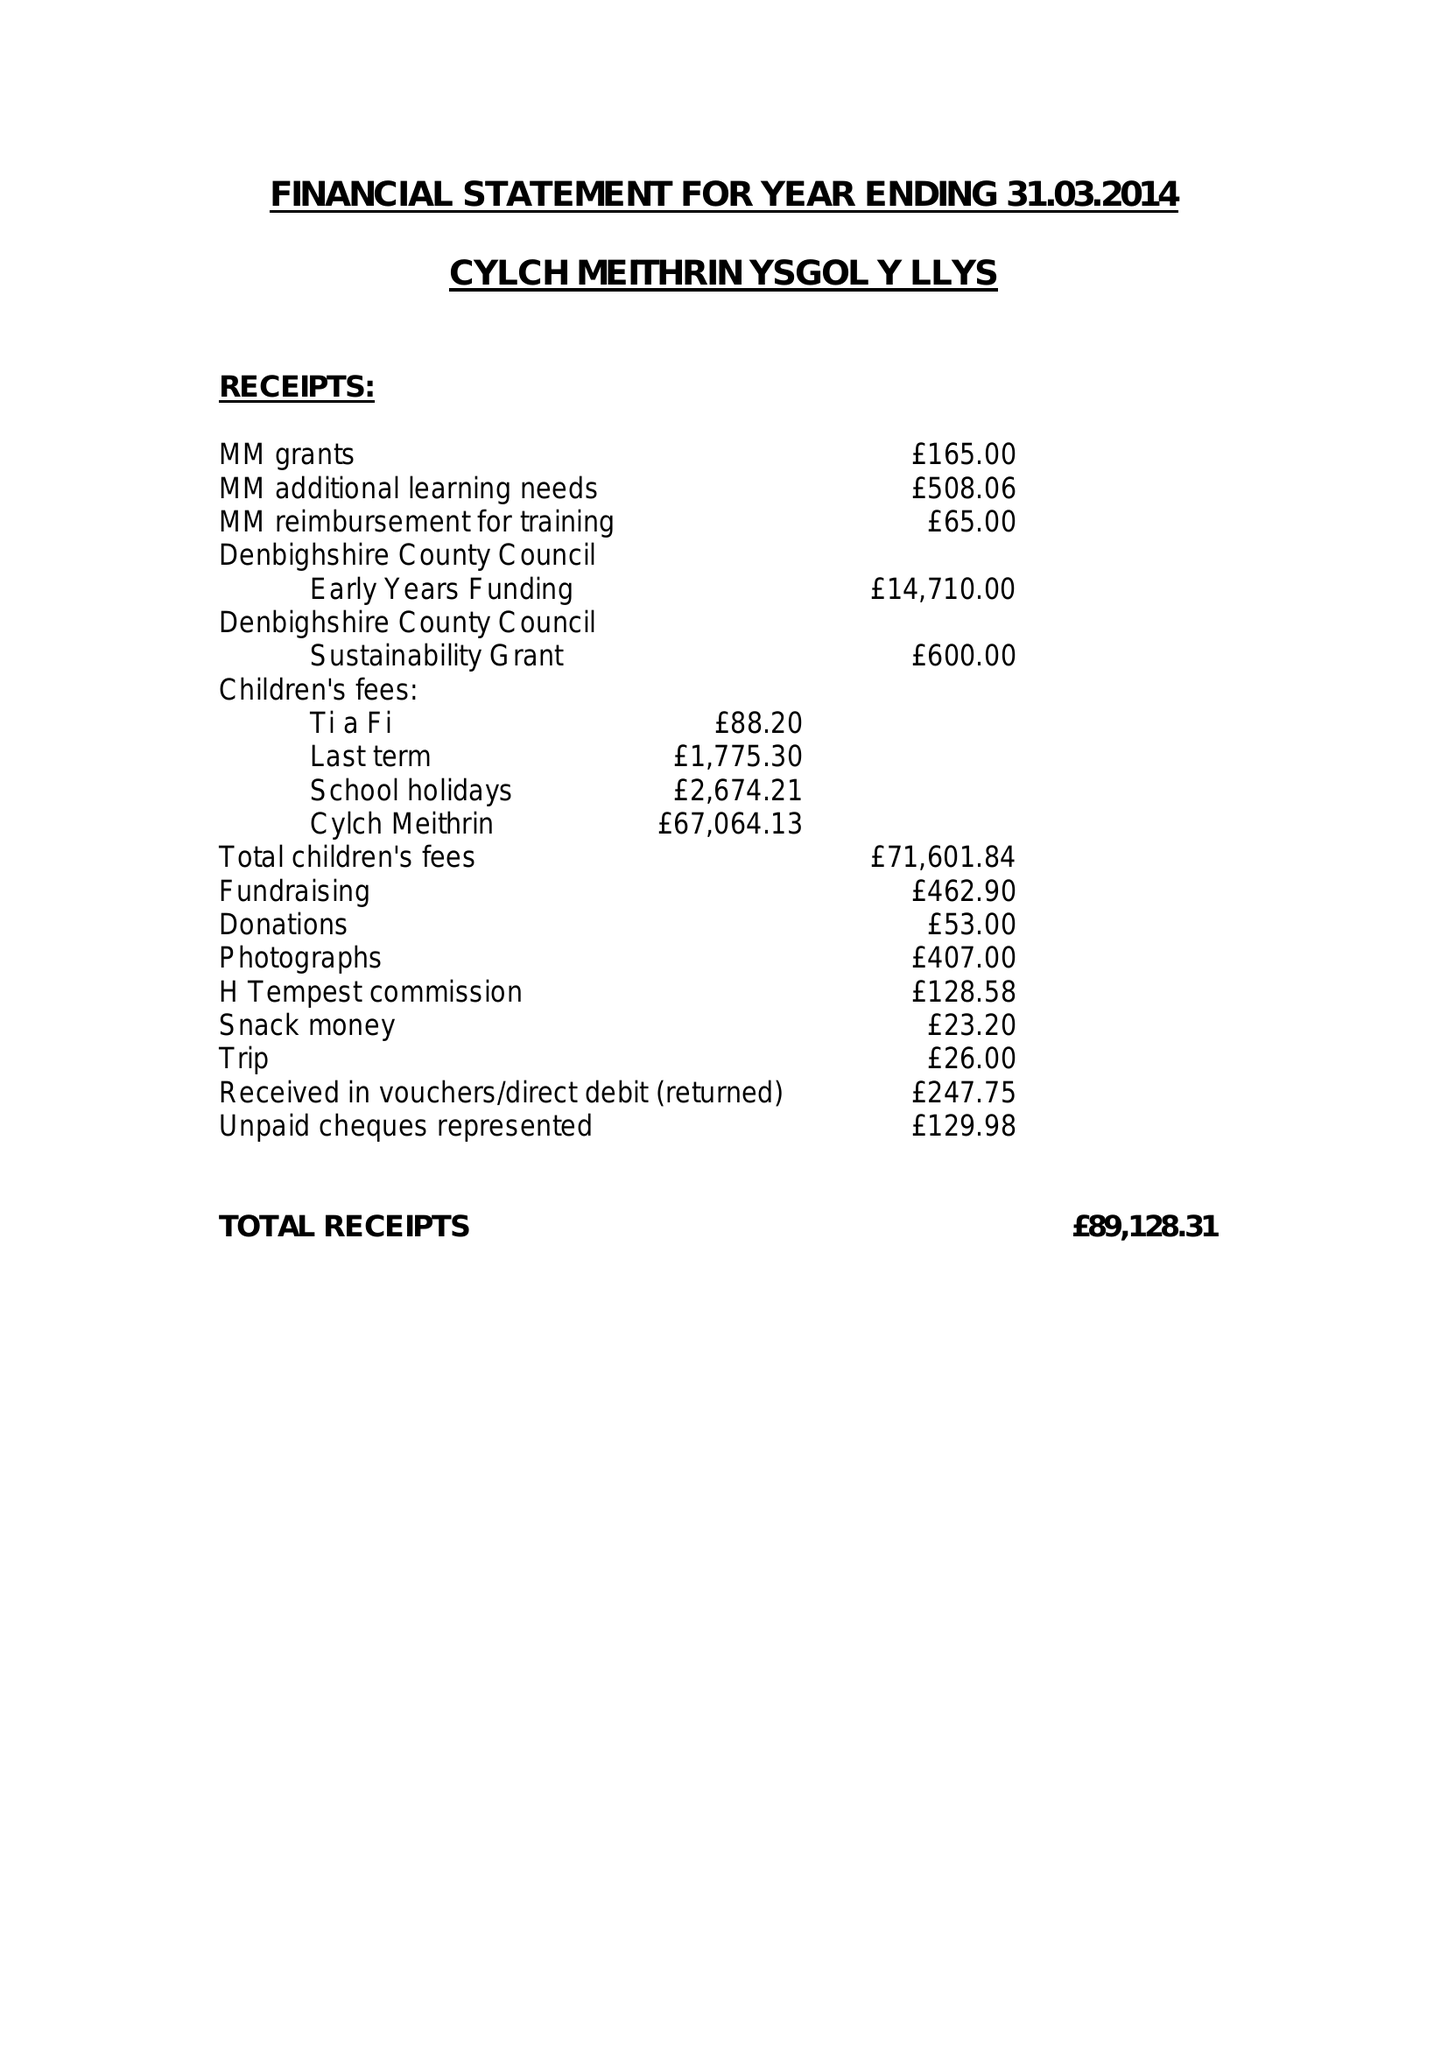What is the value for the address__street_line?
Answer the question using a single word or phrase. PRINCES AVENUE 